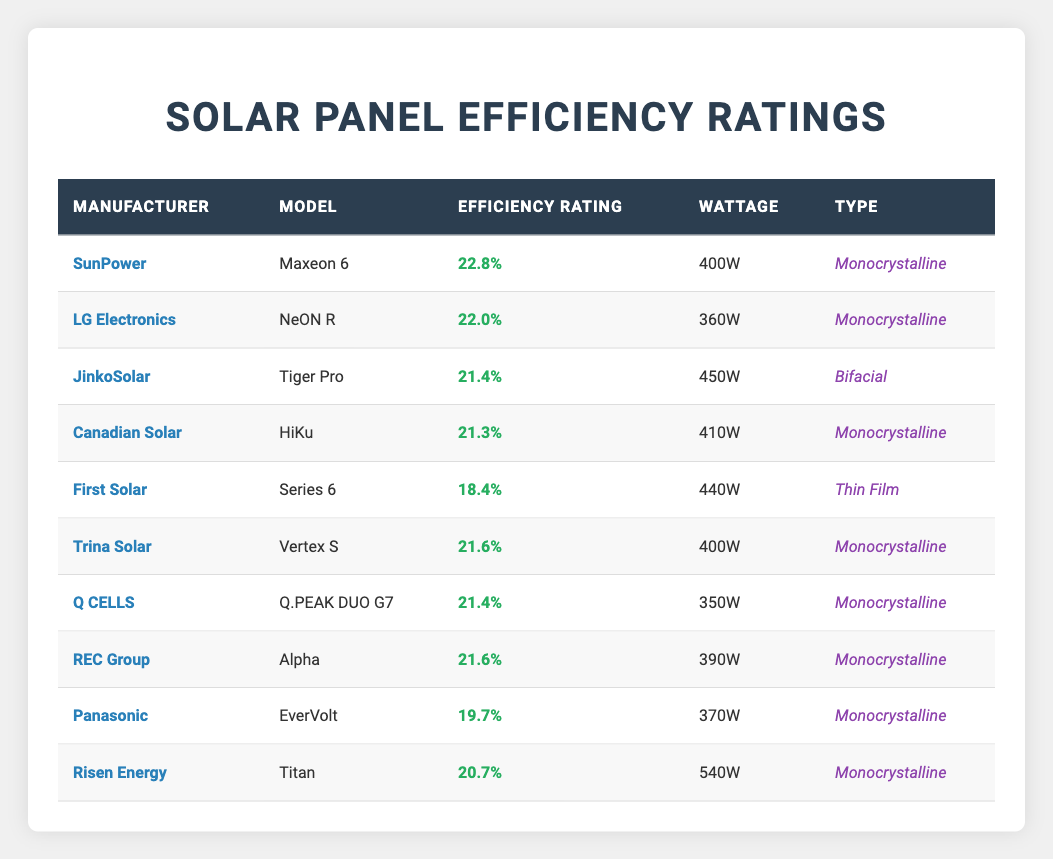What is the efficiency rating of SunPower's Maxeon 6 model? The table shows that SunPower's Maxeon 6 model has an efficiency rating of 22.8%.
Answer: 22.8% Which solar panel has the lowest efficiency rating? The table indicates that First Solar's Series 6 has the lowest efficiency rating at 18.4%.
Answer: First Solar's Series 6 What is the average efficiency rating of the Monocrystalline type panels listed? The Monocrystalline panels listed are SunPower (22.8%), LG Electronics (22.0%), Canadian Solar (21.3%), Trina Solar (21.6%), Q CELLS (21.4%), REC Group (21.6%), Panasonic (19.7%), and Risen Energy (20.7%). The average is (22.8 + 22.0 + 21.3 + 21.6 + 21.4 + 21.6 + 19.7 + 20.7) / 8 = 21.4%.
Answer: 21.4% Does JinkoSolar produce a panel with an efficiency rating above 21%? Yes, JinkoSolar’s Tiger Pro model has an efficiency rating of 21.4%, which is above 21%.
Answer: Yes How does the efficiency rating of the Canadian Solar HiKu compare to that of Risen Energy Titan? The Canadian Solar HiKu has a rating of 21.3%, while Risen Energy Titan has a rating of 20.7%. Since 21.3% is greater than 20.7%, Canadian Solar HiKu has a higher efficiency rating.
Answer: Higher Which manufacturer produces the highest efficiency rating and what is it? SunPower produces the highest efficiency rating of 22.8% with its Maxeon 6 model.
Answer: SunPower, 22.8% Count the number of manufacturers that produce Monocrystalline panels. The table lists the following manufacturers with Monocrystalline panels: SunPower, LG Electronics, Canadian Solar, Trina Solar, Q CELLS, REC Group, Panasonic, and Risen Energy. This totals 8 manufacturers.
Answer: 8 What is the total wattage of all the listed solar panels? The total wattage is calculated by summing all the individual wattages: 400 + 360 + 450 + 410 + 440 + 400 + 350 + 390 + 370 + 540 = 4,240W.
Answer: 4,240W Is there a Bifacial type panel among the listed manufacturers? Yes, JinkoSolar's Tiger Pro model is identified as a Bifacial type in the table.
Answer: Yes How many panels have an efficiency rating over 21%? The panels with an efficiency rating over 21% are: SunPower Maxeon 6 (22.8%), LG Electronics NeON R (22.0%), JinkoSolar Tiger Pro (21.4%), Trina Solar Vertex S (21.6%), Q CELLS Q.PEAK DUO G7 (21.4%), and REC Group Alpha (21.6%). This makes a total of 6 panels over 21%.
Answer: 6 